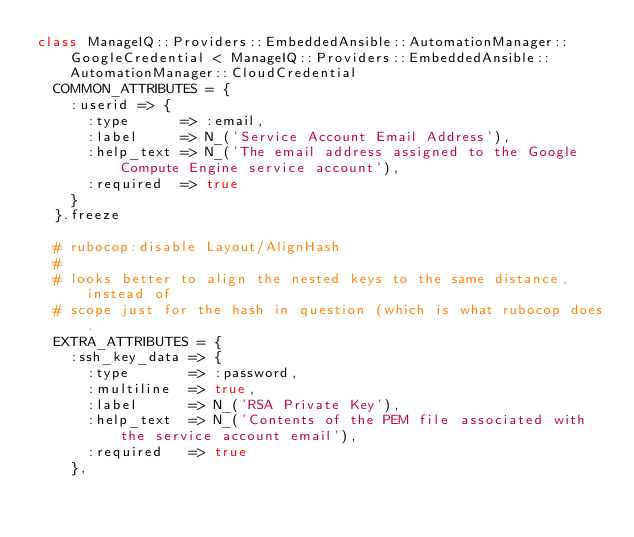Convert code to text. <code><loc_0><loc_0><loc_500><loc_500><_Ruby_>class ManageIQ::Providers::EmbeddedAnsible::AutomationManager::GoogleCredential < ManageIQ::Providers::EmbeddedAnsible::AutomationManager::CloudCredential
  COMMON_ATTRIBUTES = {
    :userid => {
      :type      => :email,
      :label     => N_('Service Account Email Address'),
      :help_text => N_('The email address assigned to the Google Compute Engine service account'),
      :required  => true
    }
  }.freeze

  # rubocop:disable Layout/AlignHash
  #
  # looks better to align the nested keys to the same distance, instead of
  # scope just for the hash in question (which is what rubocop does.
  EXTRA_ATTRIBUTES = {
    :ssh_key_data => {
      :type       => :password,
      :multiline  => true,
      :label      => N_('RSA Private Key'),
      :help_text  => N_('Contents of the PEM file associated with the service account email'),
      :required   => true
    },</code> 